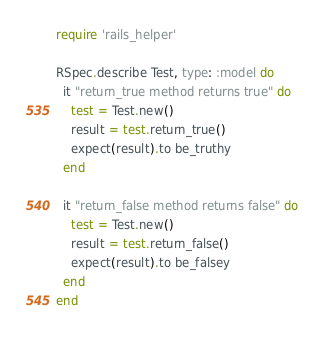<code> <loc_0><loc_0><loc_500><loc_500><_Ruby_>require 'rails_helper'

RSpec.describe Test, type: :model do
  it "return_true method returns true" do
    test = Test.new()
    result = test.return_true()
    expect(result).to be_truthy
  end

  it "return_false method returns false" do
    test = Test.new()
    result = test.return_false()
    expect(result).to be_falsey
  end
end
</code> 